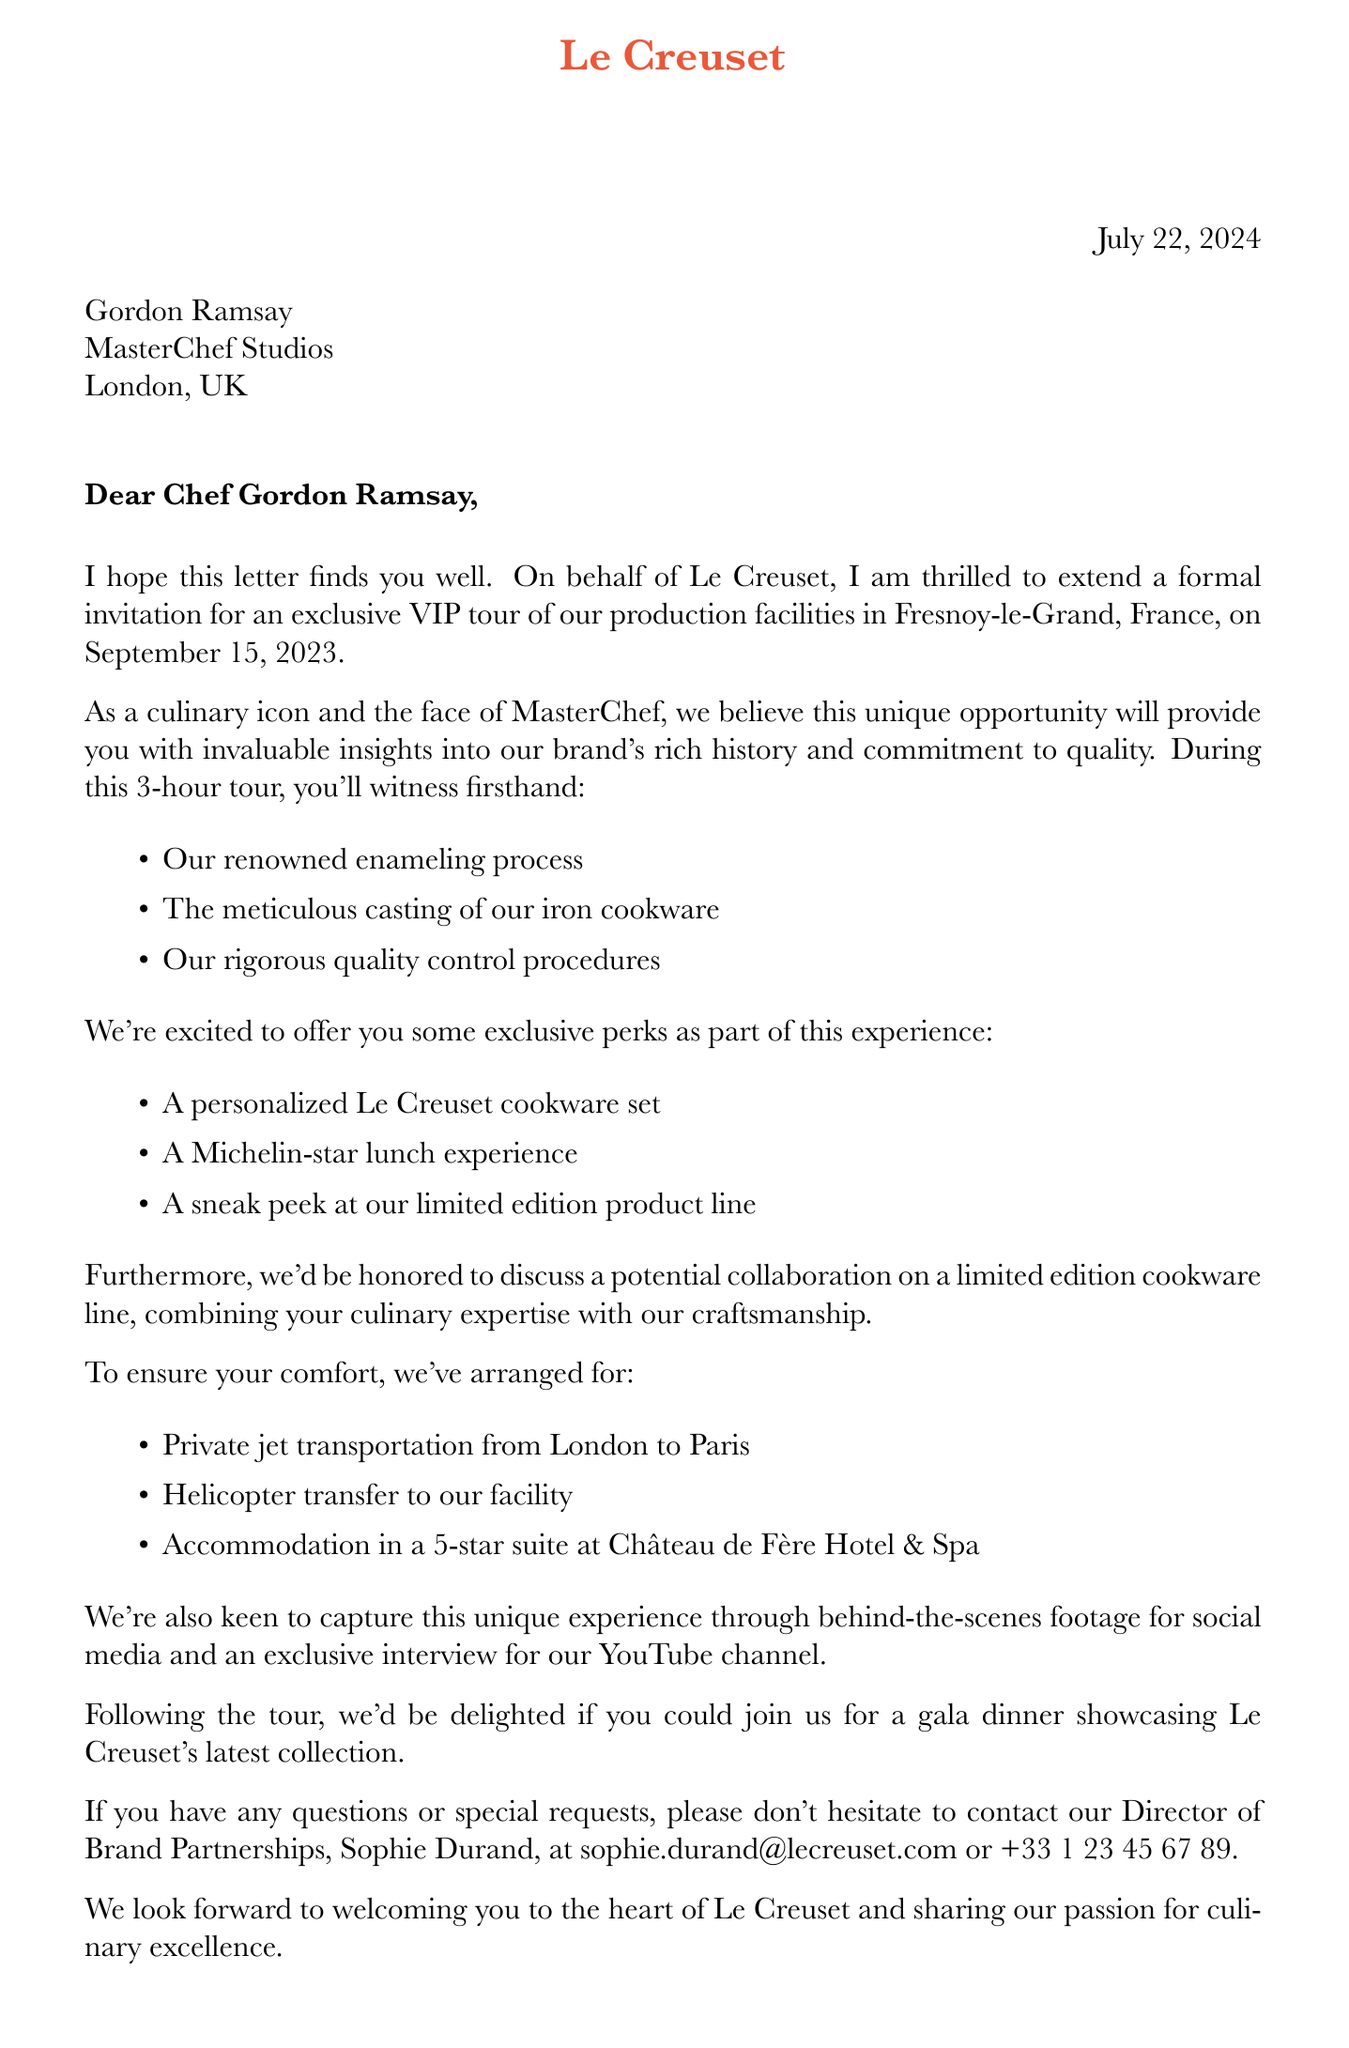What is the name of the brand? The brand mentioned in the document is Le Creuset.
Answer: Le Creuset Who is the chef receiving the invitation? The letter is addressed to Chef Gordon Ramsay.
Answer: Gordon Ramsay What is the date of the VIP tour? The tour is scheduled for September 15, 2023.
Answer: September 15, 2023 What is included in the exclusive perks? The perks include a personalized cookware set, Michelin-star lunch, and limited edition product preview.
Answer: Personalized cookware set, Michelin-star lunch experience, Limited edition product preview Where is the production facility located? The production facility is located in Fresnoy-le-Grand, France.
Answer: Fresnoy-le-Grand, France What type of transportation is arranged? The document mentions private jet transportation and helicopter transfer.
Answer: Private jet from London to Paris, followed by helicopter transfer What is the duration of the tour? The tour will last for 3 hours.
Answer: 3 hours What is the follow-up event mentioned in the letter? The letter invites Chef Ramsay to a gala dinner after the tour.
Answer: Gala dinner showcasing Le Creuset's latest collection Who should Chef Ramsay contact for questions? Chef Ramsay should contact Sophie Durand for any questions or special requests.
Answer: Sophie Durand 